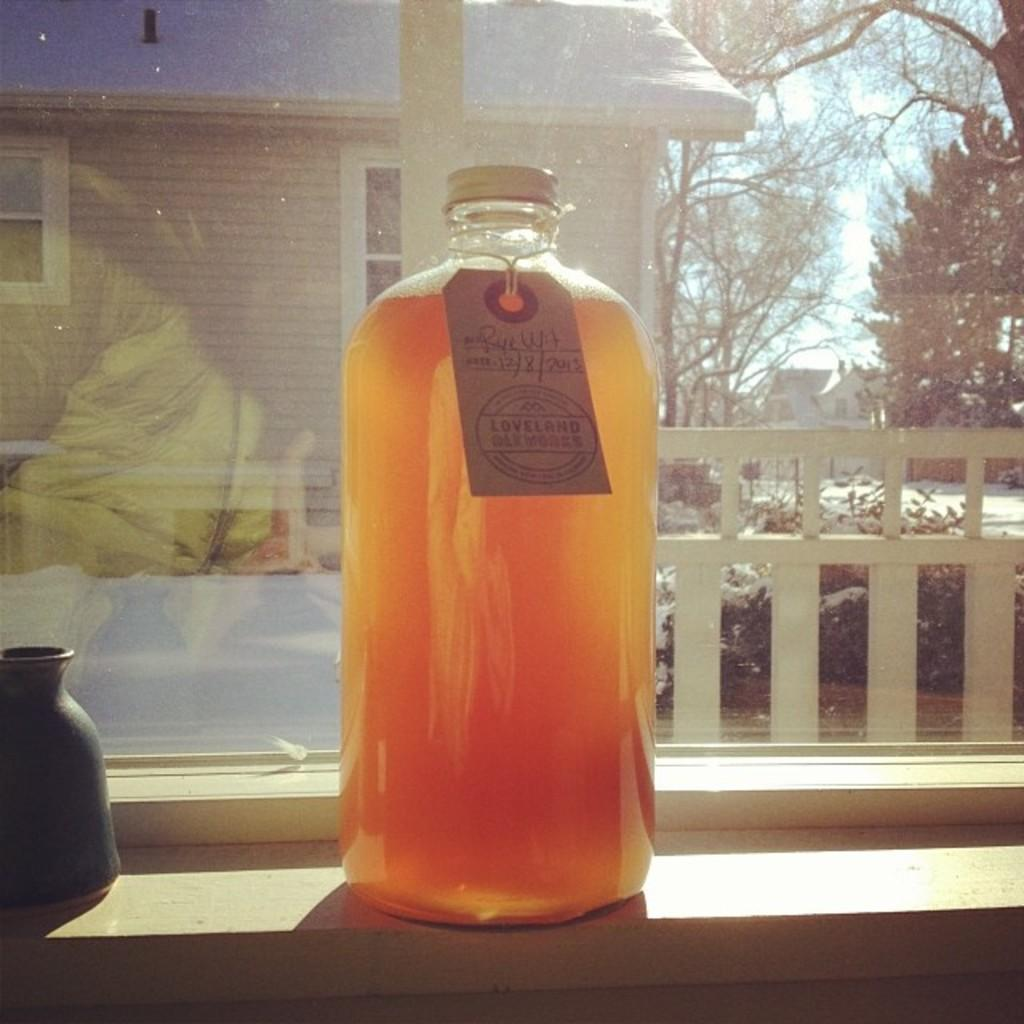<image>
Describe the image concisely. Large orange bottle of jam from Loveland placed by a window. 